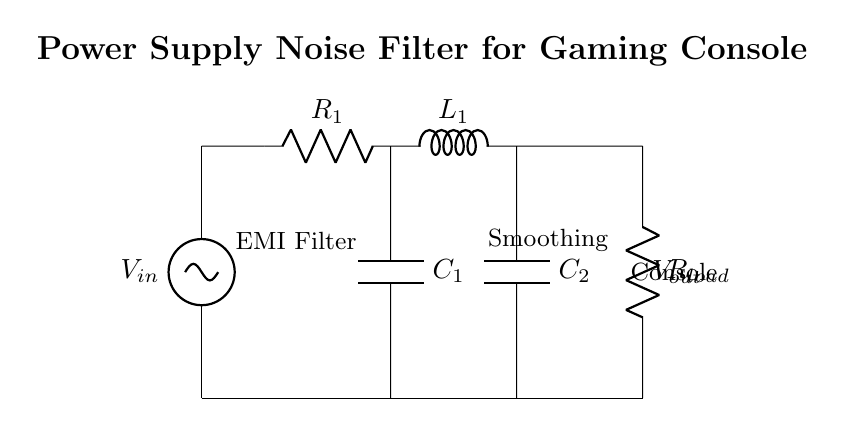What is the input voltage in this circuit? The diagram labels the input voltage as V in. Therefore, the input voltage is directly indicated in the circuit.
Answer: V in What type of filter is depicted in this circuit? The label in the circuit indicates an EMI filter, which stands for electromagnetic interference filter. It is specifically designed to reduce noise in power supplies.
Answer: EMI filter How many capacitors are present in the circuit? The circuit contains two capacitors, labeled as C1 and C2. Counting these capacitors gives the total number.
Answer: 2 What is the role of R1 in the circuit? R1 is labeled as a resistor, and it functions as part of the filter to limit current and reduce noise by dissipating energy.
Answer: Limit current How does the inductor L1 affect the circuit? L1 is part of an LC filter configuration; inductors resist changes in current, helping to suppress high-frequency noise along with the capacitors.
Answer: Suppress noise What is the output voltage labeled as in the circuit? The output voltage is labeled V out, which is the voltage across the load connected at the output of the filter.
Answer: V out What type of load is connected at the output? The load is represented by R load, indicating that it is a resistor connected to the output of the power supply.
Answer: Resistor 